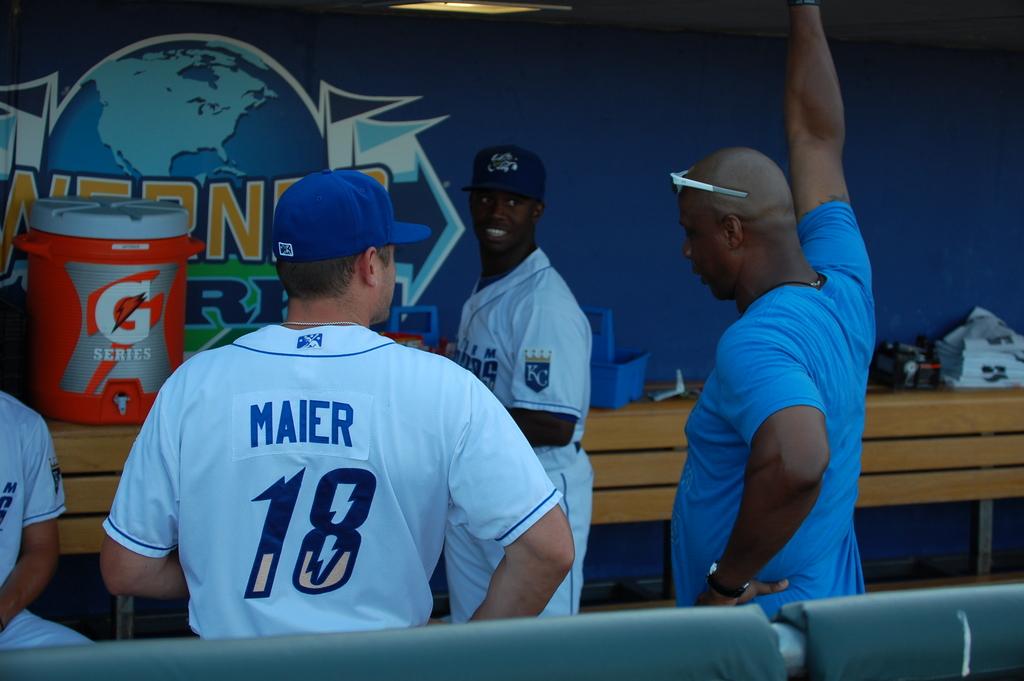What is the last name of the player?
Offer a very short reply. Maier. 